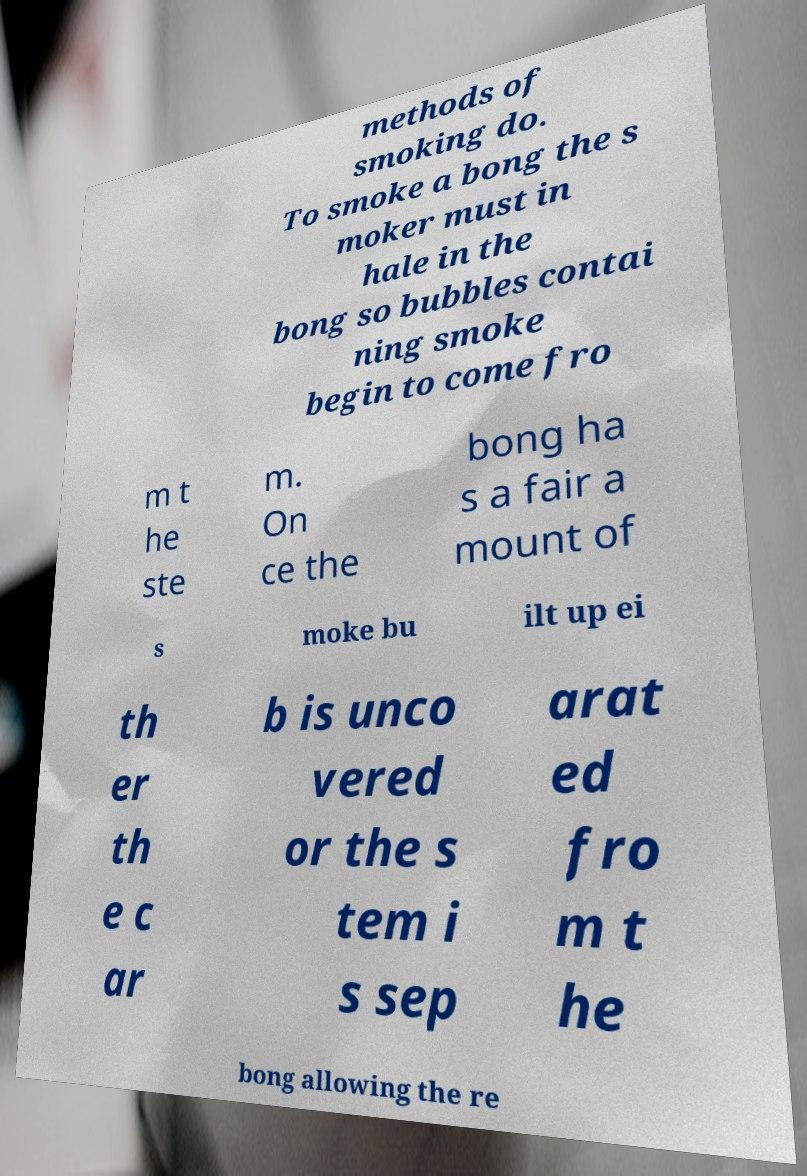Please read and relay the text visible in this image. What does it say? methods of smoking do. To smoke a bong the s moker must in hale in the bong so bubbles contai ning smoke begin to come fro m t he ste m. On ce the bong ha s a fair a mount of s moke bu ilt up ei th er th e c ar b is unco vered or the s tem i s sep arat ed fro m t he bong allowing the re 